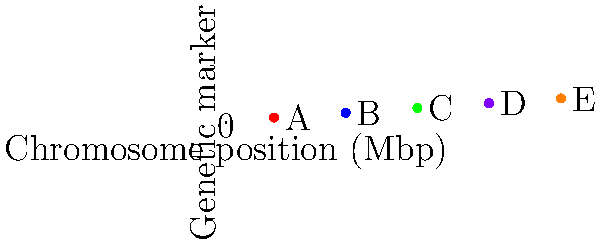Given the plot of genetic markers A, B, C, D, and E on a chromosome, which marker is located closest to the 30 Mbp position? Calculate the distance between this marker and the 30 Mbp position. To solve this problem, we need to follow these steps:

1. Identify the positions of each marker:
   A: 10 Mbp
   B: 25 Mbp
   C: 40 Mbp
   D: 55 Mbp
   E: 70 Mbp

2. Calculate the absolute difference between each marker's position and 30 Mbp:
   A: |10 - 30| = 20 Mbp
   B: |25 - 30| = 5 Mbp
   C: |40 - 30| = 10 Mbp
   D: |55 - 30| = 25 Mbp
   E: |70 - 30| = 40 Mbp

3. Identify the marker with the smallest difference:
   Marker B has the smallest difference of 5 Mbp.

4. Calculate the distance between marker B and the 30 Mbp position:
   Distance = |25 - 30| = 5 Mbp

Therefore, marker B is closest to the 30 Mbp position, and the distance between marker B and the 30 Mbp position is 5 Mbp.
Answer: Marker B; 5 Mbp 